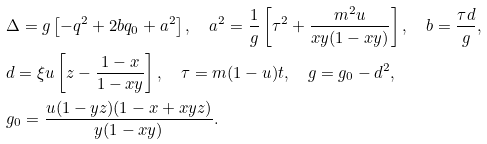<formula> <loc_0><loc_0><loc_500><loc_500>& \Delta = g \left [ - q ^ { 2 } + 2 b q _ { 0 } + a ^ { 2 } \right ] , \quad a ^ { 2 } = \frac { 1 } { g } \left [ \tau ^ { 2 } + \frac { m ^ { 2 } u } { x y ( 1 - x y ) } \right ] , \quad b = \frac { \tau d } { g } , \\ & d = \xi u \left [ z - \frac { 1 - x } { 1 - x y } \right ] , \quad \tau = m ( 1 - u ) t , \quad g = g _ { 0 } - d ^ { 2 } , \\ & g _ { 0 } = \frac { u ( 1 - y z ) ( 1 - x + x y z ) } { y ( 1 - x y ) } .</formula> 